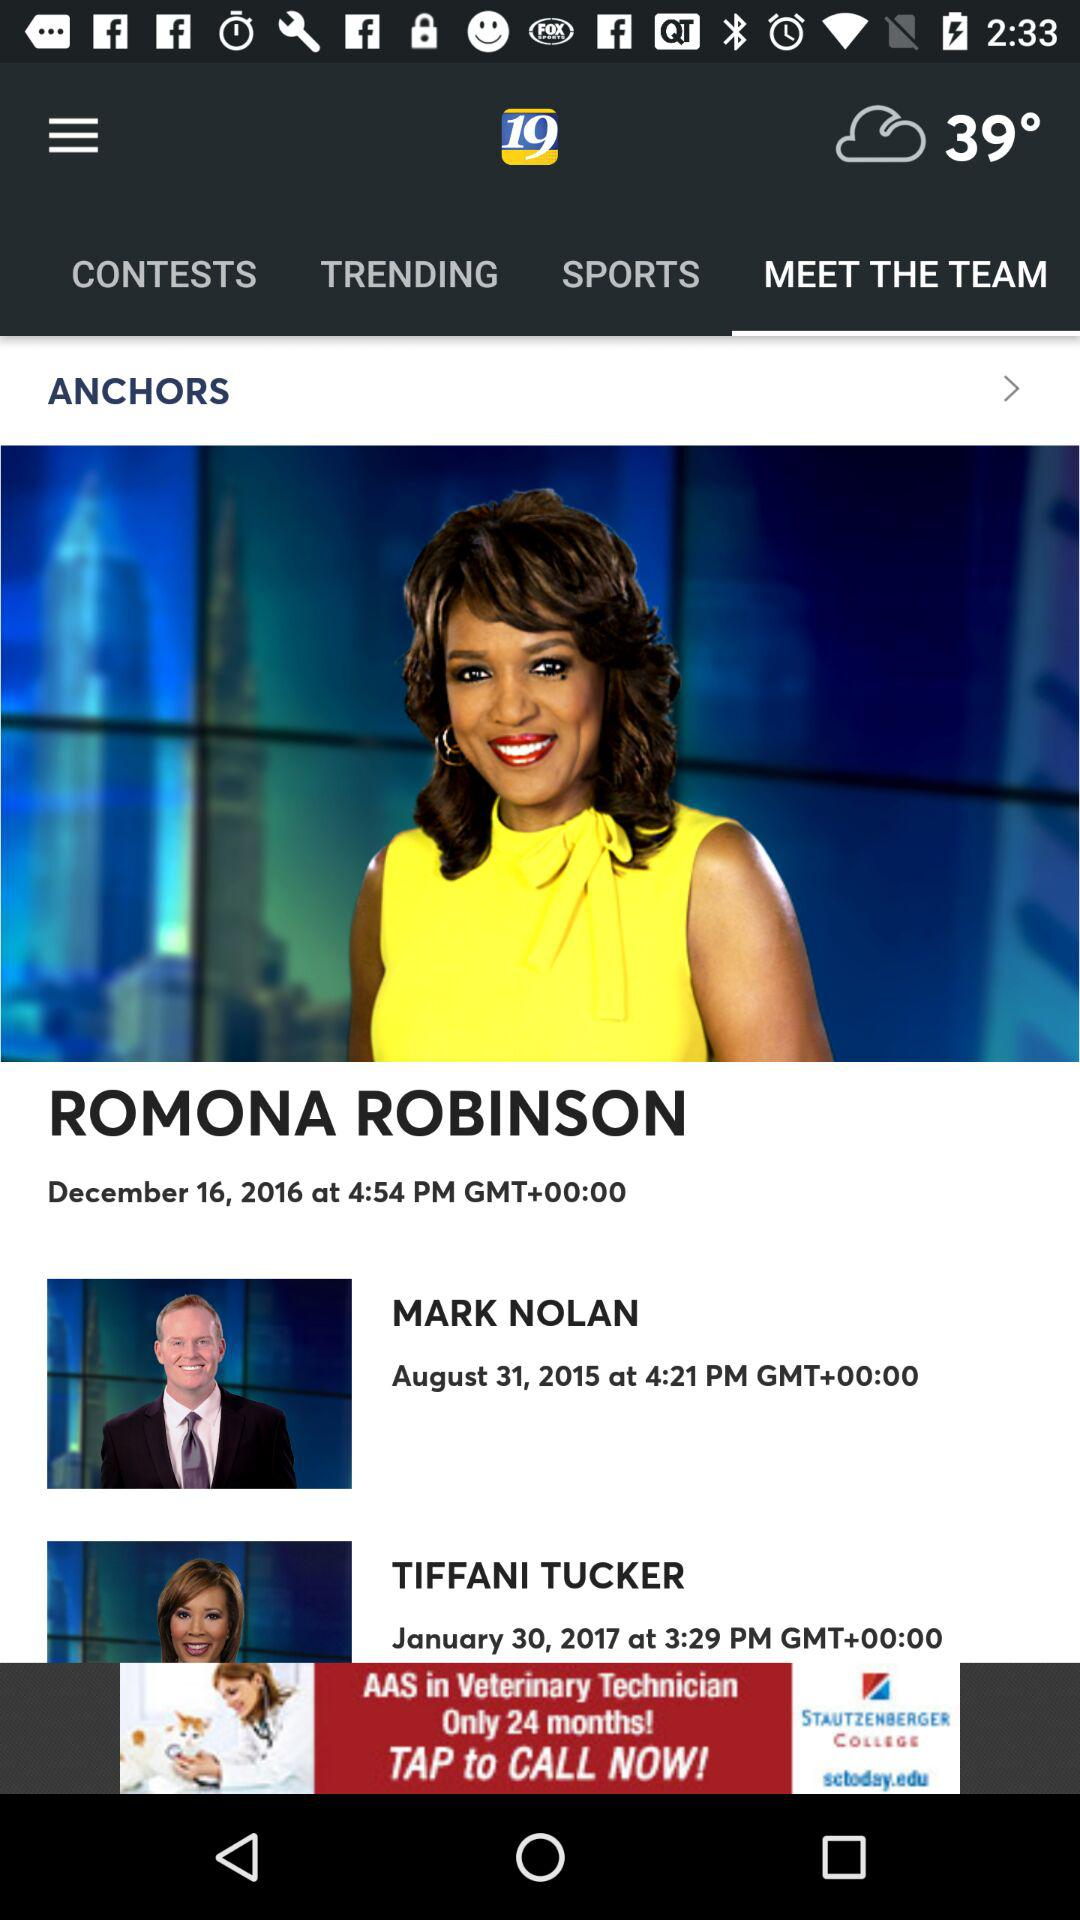At what time was the Mark Nolan show posted? The Mark Nolan show was posted at 4:21 p.m. 